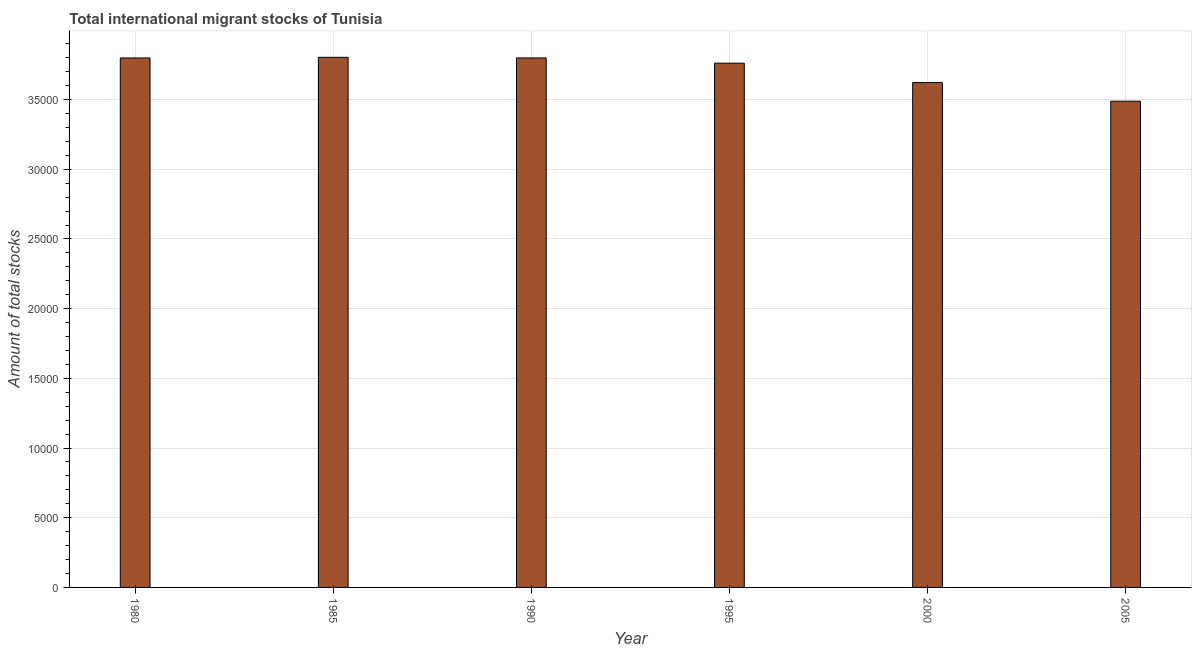Does the graph contain grids?
Your response must be concise. Yes. What is the title of the graph?
Offer a very short reply. Total international migrant stocks of Tunisia. What is the label or title of the Y-axis?
Offer a terse response. Amount of total stocks. What is the total number of international migrant stock in 1980?
Your response must be concise. 3.80e+04. Across all years, what is the maximum total number of international migrant stock?
Make the answer very short. 3.80e+04. Across all years, what is the minimum total number of international migrant stock?
Provide a succinct answer. 3.49e+04. In which year was the total number of international migrant stock maximum?
Ensure brevity in your answer.  1985. What is the sum of the total number of international migrant stock?
Offer a very short reply. 2.23e+05. What is the difference between the total number of international migrant stock in 1985 and 1995?
Ensure brevity in your answer.  417. What is the average total number of international migrant stock per year?
Ensure brevity in your answer.  3.71e+04. What is the median total number of international migrant stock?
Provide a succinct answer. 3.78e+04. Do a majority of the years between 1990 and 1980 (inclusive) have total number of international migrant stock greater than 26000 ?
Offer a very short reply. Yes. What is the ratio of the total number of international migrant stock in 1995 to that in 2005?
Your response must be concise. 1.08. Is the difference between the total number of international migrant stock in 1990 and 2005 greater than the difference between any two years?
Your answer should be very brief. No. What is the difference between the highest and the lowest total number of international migrant stock?
Provide a succinct answer. 3148. In how many years, is the total number of international migrant stock greater than the average total number of international migrant stock taken over all years?
Your response must be concise. 4. How many bars are there?
Make the answer very short. 6. How many years are there in the graph?
Ensure brevity in your answer.  6. Are the values on the major ticks of Y-axis written in scientific E-notation?
Make the answer very short. No. What is the Amount of total stocks in 1980?
Your answer should be very brief. 3.80e+04. What is the Amount of total stocks in 1985?
Keep it short and to the point. 3.80e+04. What is the Amount of total stocks of 1990?
Your response must be concise. 3.80e+04. What is the Amount of total stocks in 1995?
Your answer should be very brief. 3.76e+04. What is the Amount of total stocks in 2000?
Offer a terse response. 3.62e+04. What is the Amount of total stocks of 2005?
Your response must be concise. 3.49e+04. What is the difference between the Amount of total stocks in 1980 and 1985?
Provide a succinct answer. -44. What is the difference between the Amount of total stocks in 1980 and 1990?
Your answer should be compact. -1. What is the difference between the Amount of total stocks in 1980 and 1995?
Your answer should be compact. 373. What is the difference between the Amount of total stocks in 1980 and 2000?
Make the answer very short. 1764. What is the difference between the Amount of total stocks in 1980 and 2005?
Keep it short and to the point. 3104. What is the difference between the Amount of total stocks in 1985 and 1995?
Offer a terse response. 417. What is the difference between the Amount of total stocks in 1985 and 2000?
Your answer should be compact. 1808. What is the difference between the Amount of total stocks in 1985 and 2005?
Provide a succinct answer. 3148. What is the difference between the Amount of total stocks in 1990 and 1995?
Offer a very short reply. 374. What is the difference between the Amount of total stocks in 1990 and 2000?
Your response must be concise. 1765. What is the difference between the Amount of total stocks in 1990 and 2005?
Your response must be concise. 3105. What is the difference between the Amount of total stocks in 1995 and 2000?
Your answer should be very brief. 1391. What is the difference between the Amount of total stocks in 1995 and 2005?
Keep it short and to the point. 2731. What is the difference between the Amount of total stocks in 2000 and 2005?
Offer a terse response. 1340. What is the ratio of the Amount of total stocks in 1980 to that in 1985?
Your response must be concise. 1. What is the ratio of the Amount of total stocks in 1980 to that in 1990?
Keep it short and to the point. 1. What is the ratio of the Amount of total stocks in 1980 to that in 2000?
Your answer should be very brief. 1.05. What is the ratio of the Amount of total stocks in 1980 to that in 2005?
Your answer should be very brief. 1.09. What is the ratio of the Amount of total stocks in 1985 to that in 1990?
Your response must be concise. 1. What is the ratio of the Amount of total stocks in 1985 to that in 1995?
Provide a short and direct response. 1.01. What is the ratio of the Amount of total stocks in 1985 to that in 2000?
Your response must be concise. 1.05. What is the ratio of the Amount of total stocks in 1985 to that in 2005?
Your answer should be compact. 1.09. What is the ratio of the Amount of total stocks in 1990 to that in 2000?
Offer a very short reply. 1.05. What is the ratio of the Amount of total stocks in 1990 to that in 2005?
Offer a terse response. 1.09. What is the ratio of the Amount of total stocks in 1995 to that in 2000?
Make the answer very short. 1.04. What is the ratio of the Amount of total stocks in 1995 to that in 2005?
Give a very brief answer. 1.08. What is the ratio of the Amount of total stocks in 2000 to that in 2005?
Give a very brief answer. 1.04. 